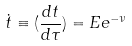<formula> <loc_0><loc_0><loc_500><loc_500>\dot { t } \equiv ( \frac { d t } { d \tau } ) = E e ^ { - \nu }</formula> 